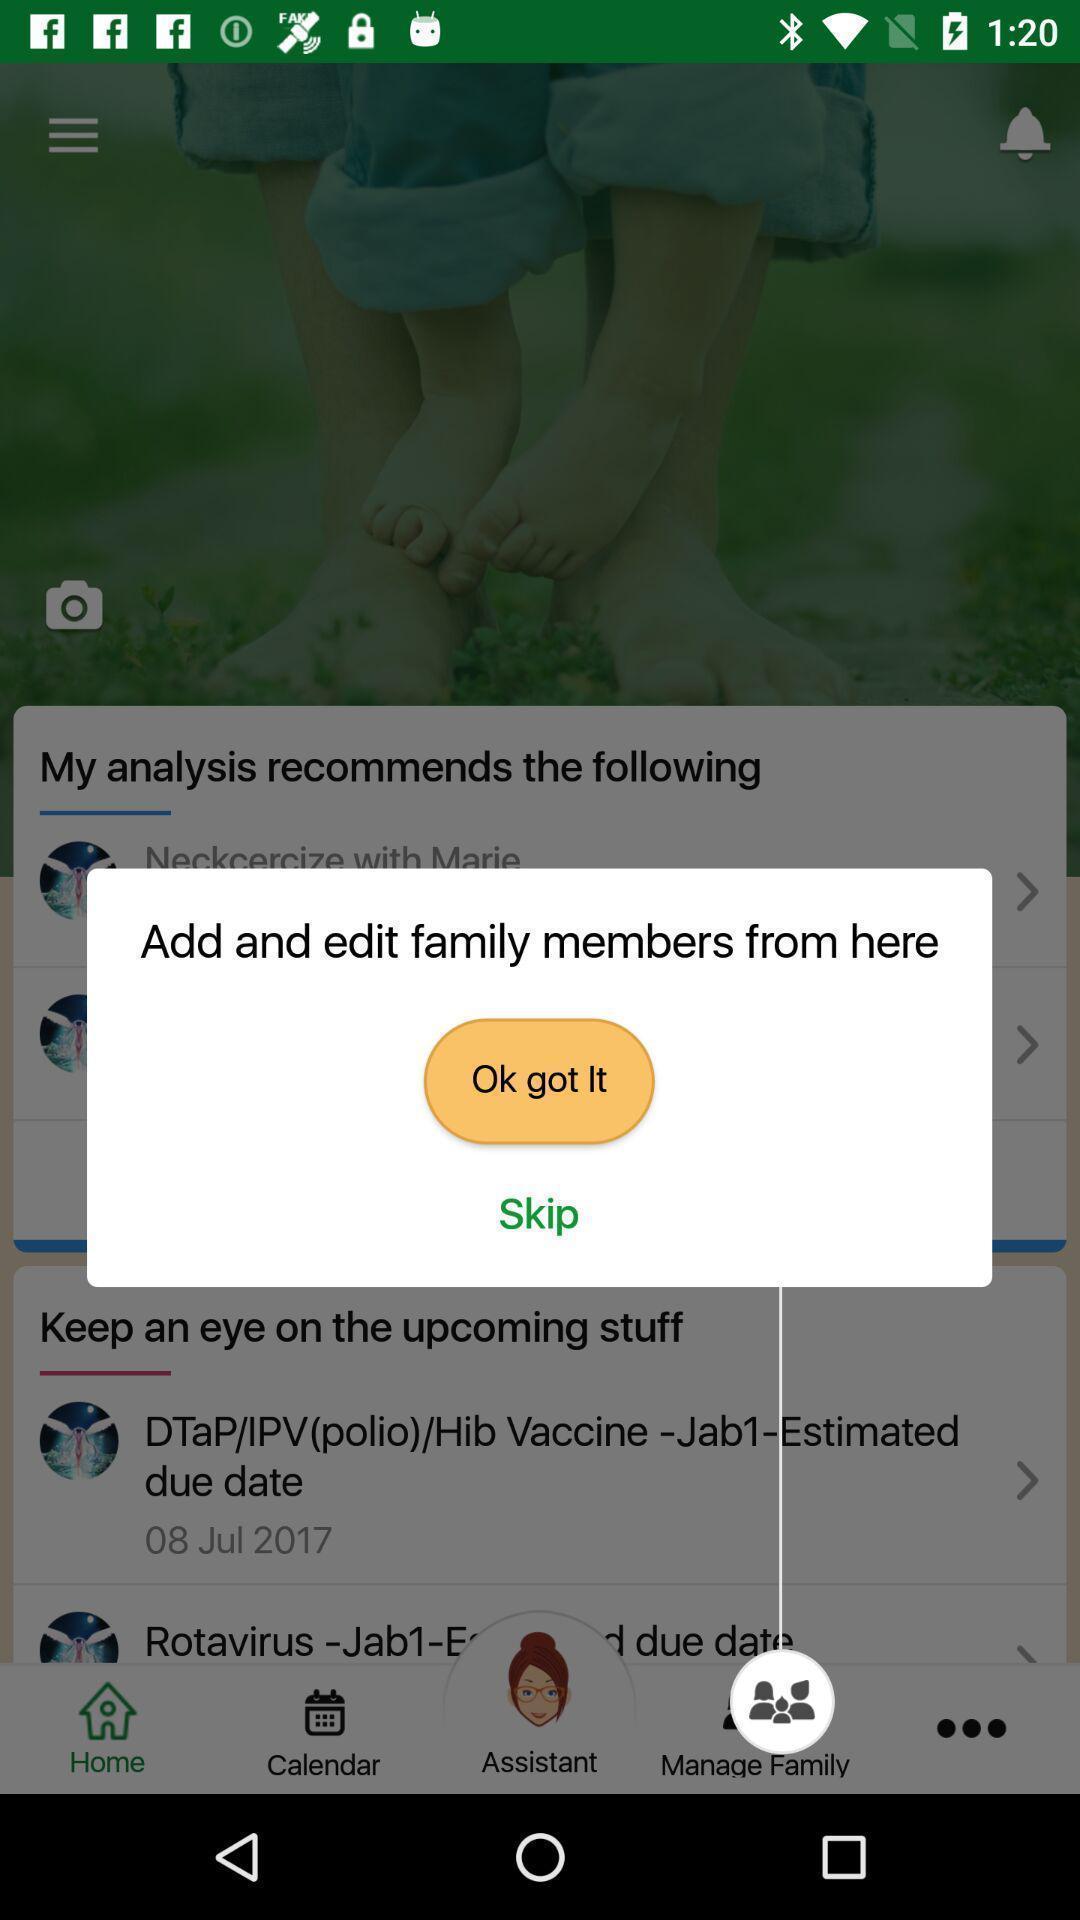Describe this image in words. Popup to add members in the parenting app. 